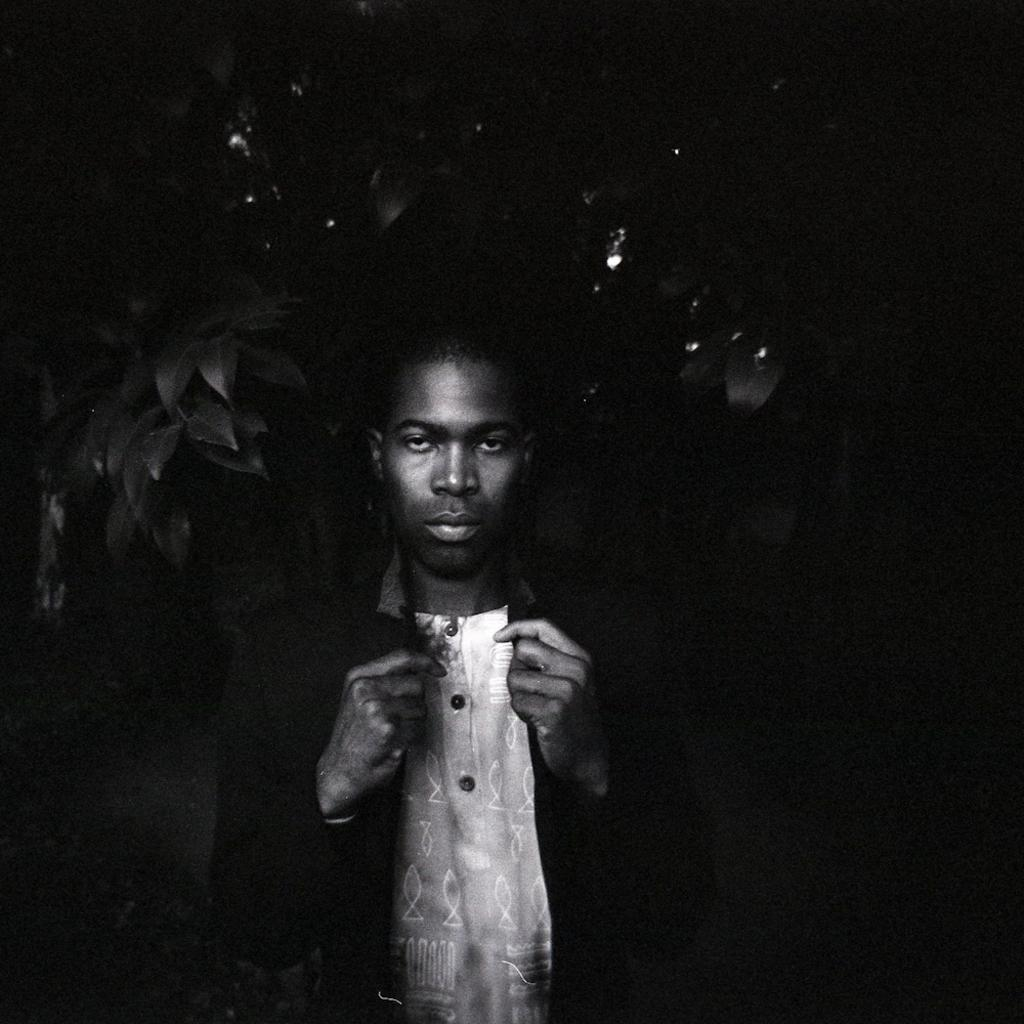What is the color scheme of the image? The image is black and white. Can you identify any human presence in the image? Yes, there is a person in the image. What type of natural element is present in the image? There is a tree in the image. What is the color of the background in the image? The background of the image is dark. Can you tell me how many cans are visible in the image? There are no cans present in the image. What type of cap is the person wearing in the image? There is no cap visible in the image. What is the father of the person doing in the image? There is no father or any other person besides the one visible in the image. 